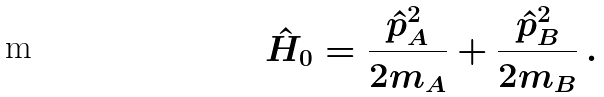Convert formula to latex. <formula><loc_0><loc_0><loc_500><loc_500>\hat { H } _ { 0 } = \frac { \hat { p } _ { A } ^ { 2 } } { 2 m _ { A } } + \frac { \hat { p } _ { B } ^ { 2 } } { 2 m _ { B } } \, .</formula> 